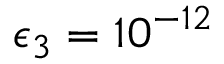Convert formula to latex. <formula><loc_0><loc_0><loc_500><loc_500>\epsilon _ { 3 } = 1 0 ^ { - 1 2 }</formula> 